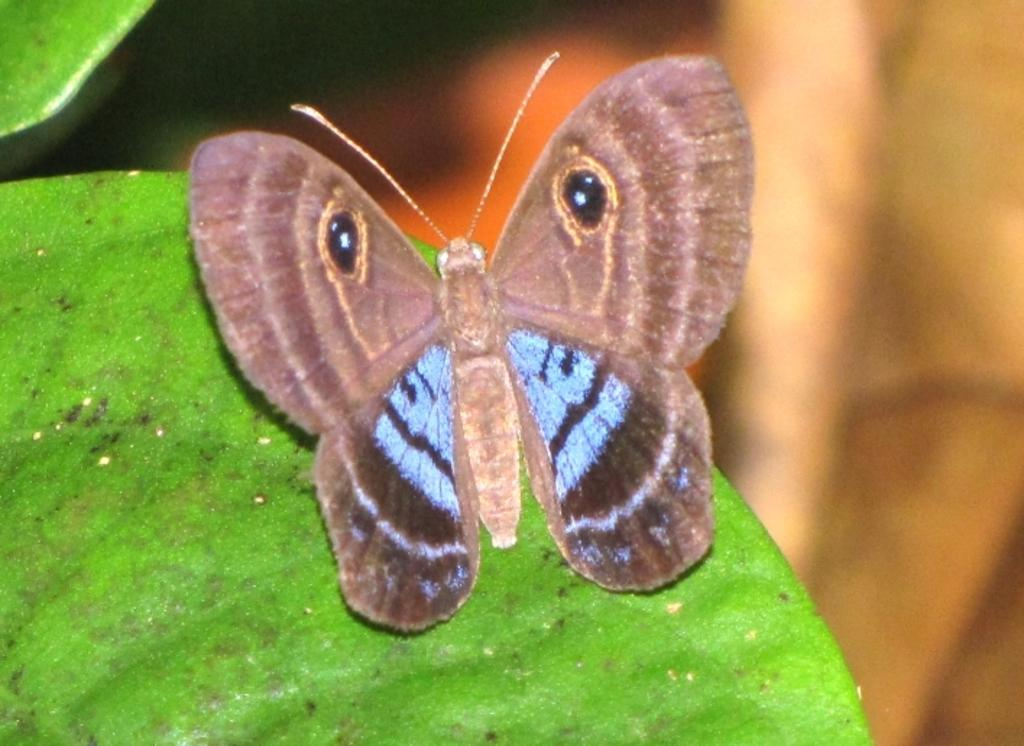What is the main subject of the image? There is a butterfly in the image. Can you describe the colors of the butterfly? The butterfly has white and brown colors. Where is the butterfly located in the image? The butterfly is on a green leaf. How would you describe the background of the image? The background of the image is blurred. What time is displayed on the hour in the image? There is no hour or clock present in the image; it features a butterfly on a green leaf. What type of basin is visible in the image? There is no basin present in the image. 